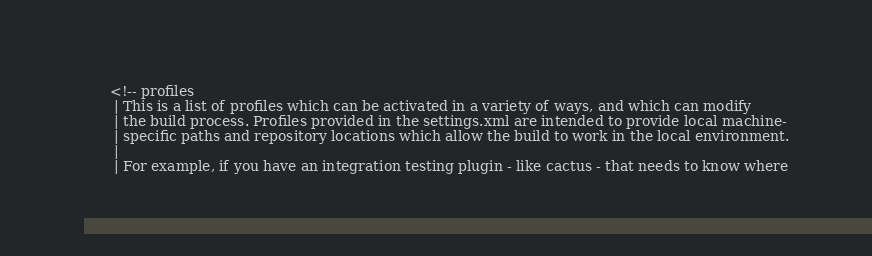<code> <loc_0><loc_0><loc_500><loc_500><_YAML_>      <!-- profiles
       | This is a list of profiles which can be activated in a variety of ways, and which can modify
       | the build process. Profiles provided in the settings.xml are intended to provide local machine-
       | specific paths and repository locations which allow the build to work in the local environment.
       |
       | For example, if you have an integration testing plugin - like cactus - that needs to know where</code> 